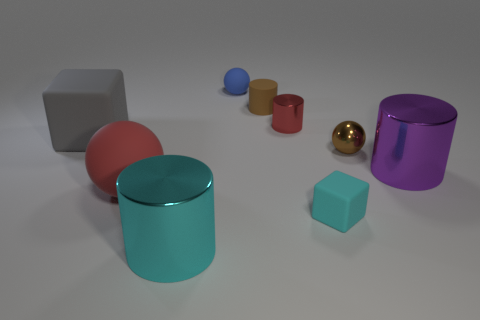Add 1 big rubber spheres. How many objects exist? 10 Subtract all cylinders. How many objects are left? 5 Add 8 big matte balls. How many big matte balls are left? 9 Add 7 big blue cylinders. How many big blue cylinders exist? 7 Subtract 0 red blocks. How many objects are left? 9 Subtract all large blue matte cylinders. Subtract all big cubes. How many objects are left? 8 